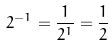<formula> <loc_0><loc_0><loc_500><loc_500>2 ^ { - 1 } = \frac { 1 } { 2 ^ { 1 } } = \frac { 1 } { 2 }</formula> 